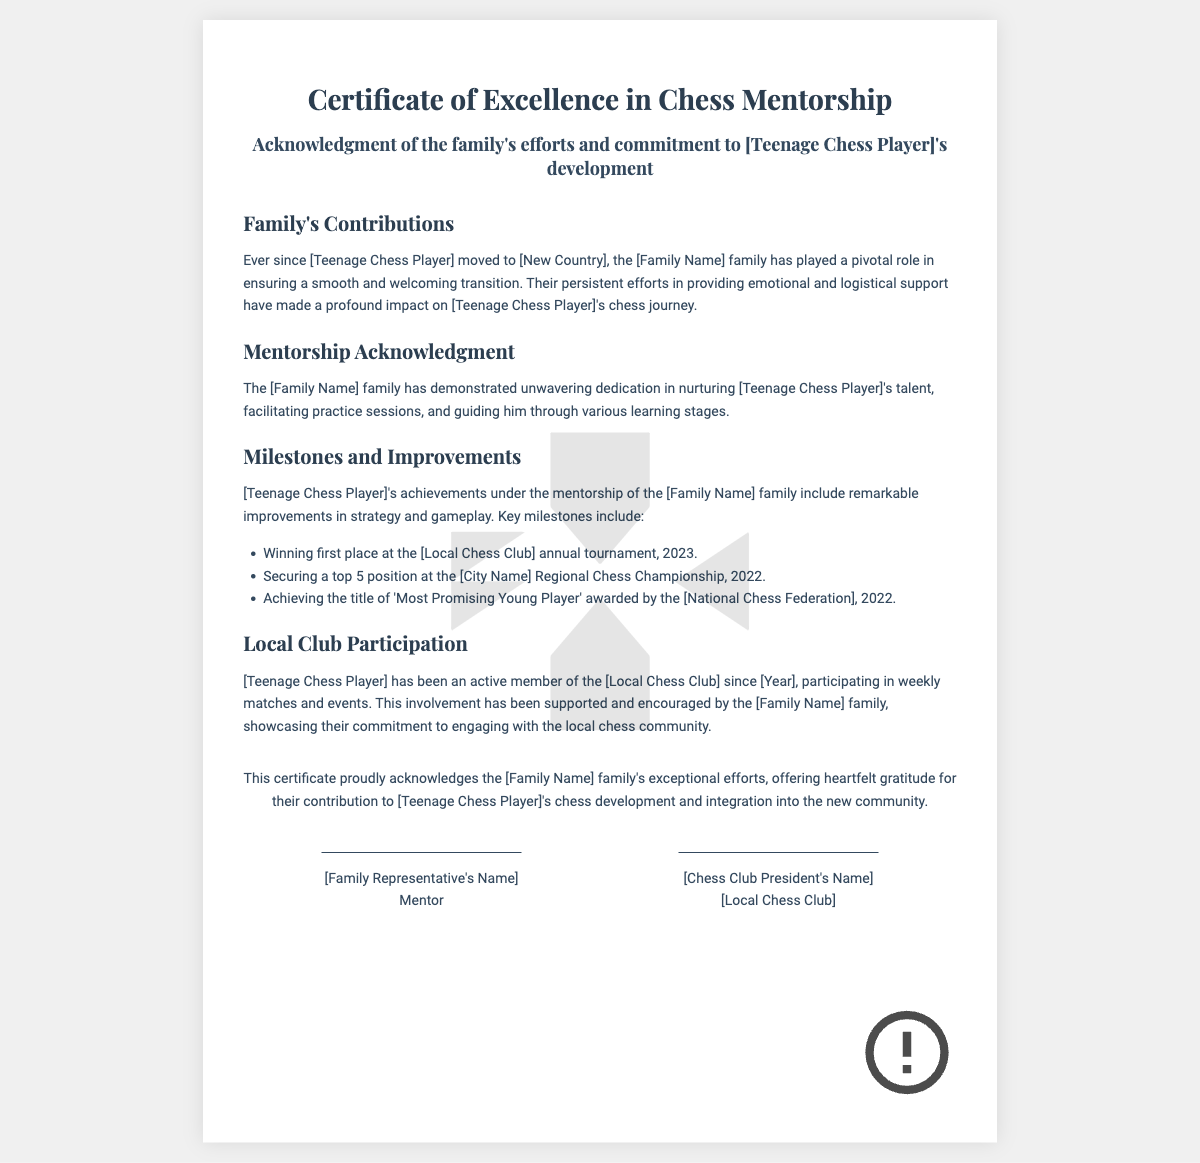What is the title of the certificate? The title is presented at the top of the certificate and indicates the purpose of the document.
Answer: Certificate of Excellence in Chess Mentorship Who is the certificate acknowledging? The acknowledgment is made to a specific individual mentioned in the document.
Answer: [Teenage Chess Player] What is the name of the family? The family's name is indicated as the primary contributor to the chess player's development.
Answer: [Family Name] What milestone did the teenage chess player achieve in 2023? The milestone is listed as a specific achievement that highlights the player's success in events.
Answer: Winning first place at the [Local Chess Club] annual tournament What award did the teenage chess player receive in 2022? The award is noted as a significant recognition of the player's progress in chess.
Answer: 'Most Promising Young Player' Since what year has the teenage chess player been a member of the local chess club? This information refers to the beginning of the player's engagement with the local chess community.
Answer: [Year] Who signed the certificate as a representative of the family? The signature deemed significant for acknowledging the family’s contributions is indicated in the document.
Answer: [Family Representative's Name] How does the family contribute to the player's integration into the community? The contribution is explained in terms of the family’s actions and support for the player in adapting to the new environment.
Answer: Providing emotional and logistical support What is the purpose of the certificate? The purpose is particularly outlined in the introduction of the document with specific emphasis.
Answer: Acknowledgment of the family's efforts and commitment 